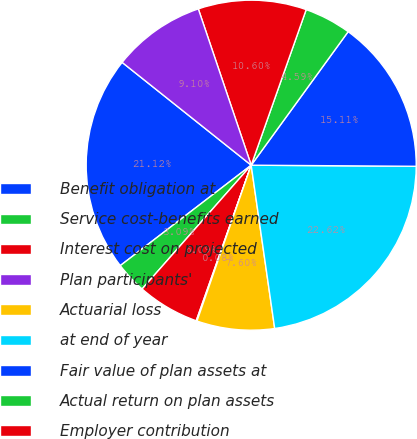Convert chart. <chart><loc_0><loc_0><loc_500><loc_500><pie_chart><fcel>Benefit obligation at<fcel>Service cost-benefits earned<fcel>Interest cost on projected<fcel>Plan participants'<fcel>Actuarial loss<fcel>at end of year<fcel>Fair value of plan assets at<fcel>Actual return on plan assets<fcel>Employer contribution<fcel>Benefits paid<nl><fcel>21.12%<fcel>3.09%<fcel>6.09%<fcel>0.08%<fcel>7.6%<fcel>22.62%<fcel>15.11%<fcel>4.59%<fcel>10.6%<fcel>9.1%<nl></chart> 